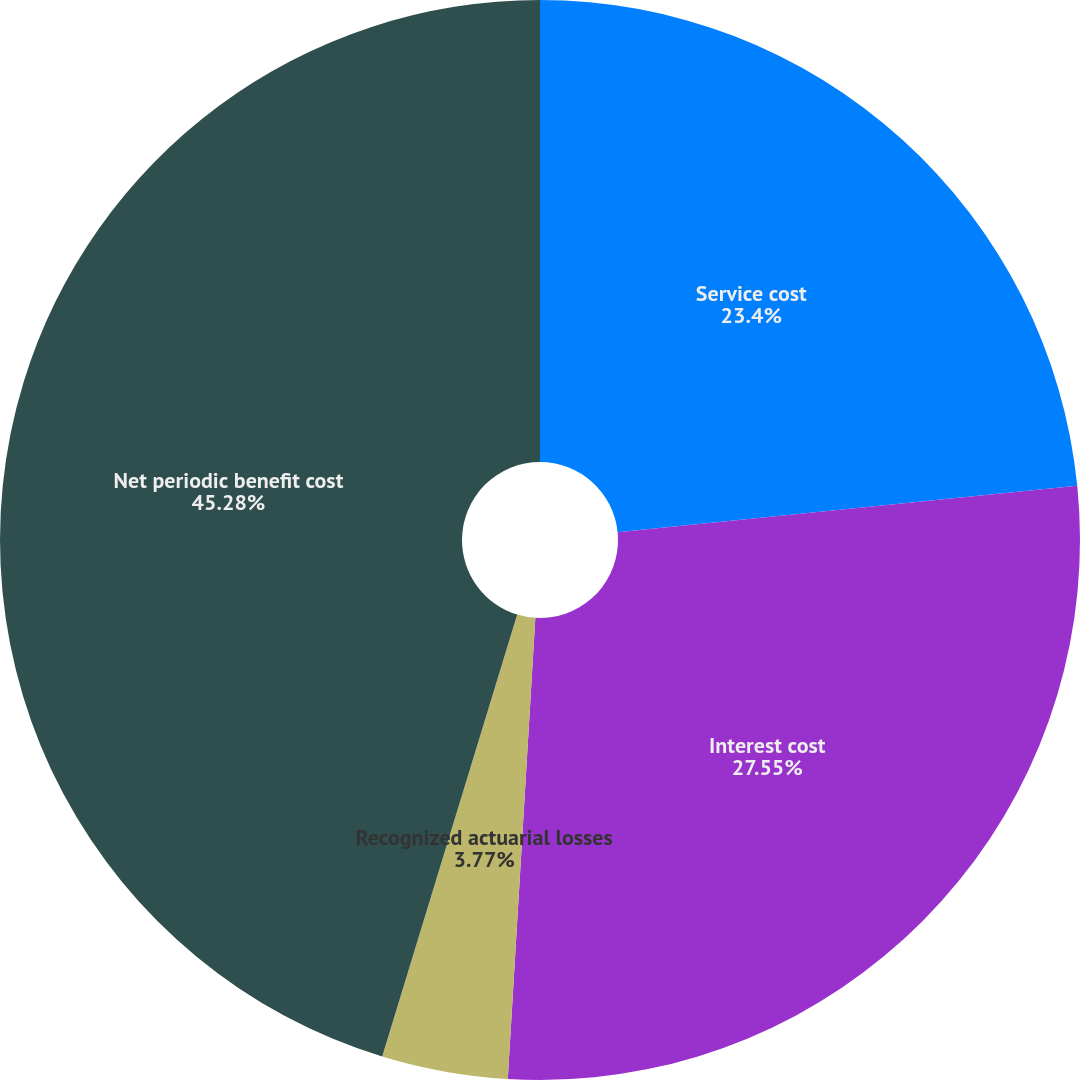Convert chart to OTSL. <chart><loc_0><loc_0><loc_500><loc_500><pie_chart><fcel>Service cost<fcel>Interest cost<fcel>Recognized actuarial losses<fcel>Net periodic benefit cost<nl><fcel>23.4%<fcel>27.55%<fcel>3.77%<fcel>45.28%<nl></chart> 